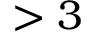Convert formula to latex. <formula><loc_0><loc_0><loc_500><loc_500>> 3</formula> 